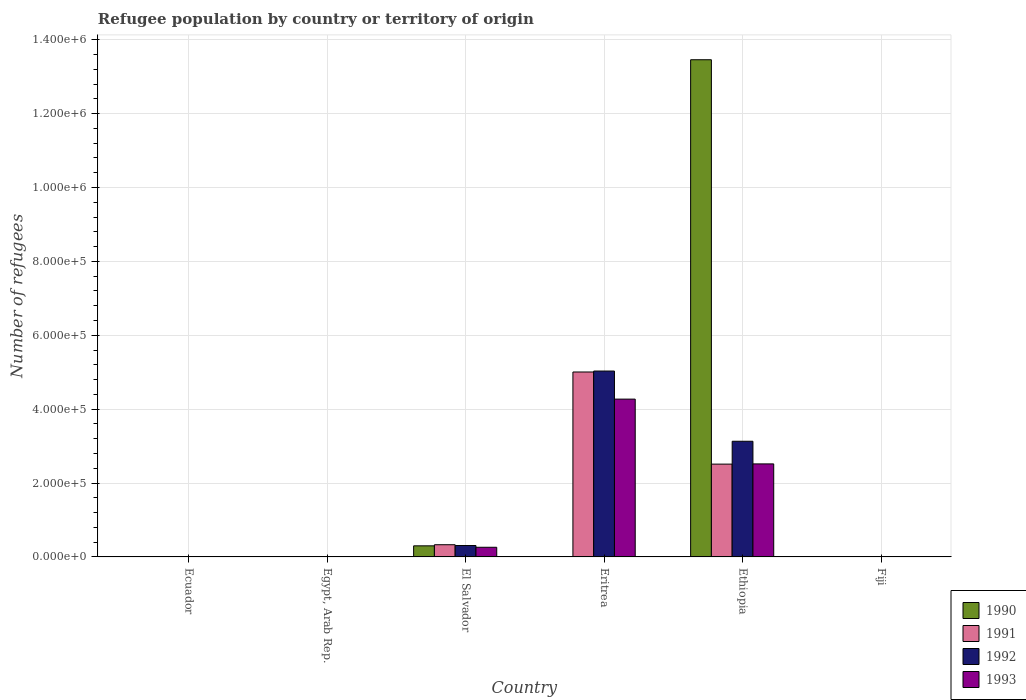How many different coloured bars are there?
Your answer should be very brief. 4. How many groups of bars are there?
Provide a succinct answer. 6. Are the number of bars on each tick of the X-axis equal?
Offer a terse response. Yes. How many bars are there on the 1st tick from the left?
Offer a very short reply. 4. What is the label of the 1st group of bars from the left?
Offer a terse response. Ecuador. What is the number of refugees in 1992 in Egypt, Arab Rep.?
Make the answer very short. 209. Across all countries, what is the maximum number of refugees in 1991?
Provide a succinct answer. 5.01e+05. In which country was the number of refugees in 1993 maximum?
Offer a very short reply. Eritrea. In which country was the number of refugees in 1993 minimum?
Keep it short and to the point. Ecuador. What is the total number of refugees in 1992 in the graph?
Offer a very short reply. 8.47e+05. What is the difference between the number of refugees in 1993 in Ethiopia and that in Fiji?
Your answer should be compact. 2.52e+05. What is the difference between the number of refugees in 1992 in Eritrea and the number of refugees in 1990 in Egypt, Arab Rep.?
Your response must be concise. 5.03e+05. What is the average number of refugees in 1992 per country?
Provide a succinct answer. 1.41e+05. What is the ratio of the number of refugees in 1993 in El Salvador to that in Eritrea?
Offer a very short reply. 0.06. Is the difference between the number of refugees in 1991 in Ethiopia and Fiji greater than the difference between the number of refugees in 1993 in Ethiopia and Fiji?
Your answer should be compact. No. What is the difference between the highest and the second highest number of refugees in 1991?
Offer a very short reply. 2.49e+05. What is the difference between the highest and the lowest number of refugees in 1990?
Your answer should be compact. 1.35e+06. What does the 1st bar from the right in Ethiopia represents?
Make the answer very short. 1993. Is it the case that in every country, the sum of the number of refugees in 1992 and number of refugees in 1991 is greater than the number of refugees in 1990?
Keep it short and to the point. No. How many bars are there?
Provide a short and direct response. 24. Are all the bars in the graph horizontal?
Your response must be concise. No. What is the difference between two consecutive major ticks on the Y-axis?
Provide a succinct answer. 2.00e+05. Does the graph contain any zero values?
Your response must be concise. No. Does the graph contain grids?
Keep it short and to the point. Yes. How many legend labels are there?
Your answer should be very brief. 4. How are the legend labels stacked?
Your answer should be compact. Vertical. What is the title of the graph?
Your answer should be compact. Refugee population by country or territory of origin. Does "1991" appear as one of the legend labels in the graph?
Offer a terse response. Yes. What is the label or title of the X-axis?
Your response must be concise. Country. What is the label or title of the Y-axis?
Give a very brief answer. Number of refugees. What is the Number of refugees in 1990 in Ecuador?
Make the answer very short. 3. What is the Number of refugees in 1991 in Ecuador?
Your answer should be compact. 27. What is the Number of refugees in 1991 in Egypt, Arab Rep.?
Your answer should be very brief. 97. What is the Number of refugees in 1992 in Egypt, Arab Rep.?
Provide a succinct answer. 209. What is the Number of refugees in 1993 in Egypt, Arab Rep.?
Your answer should be compact. 258. What is the Number of refugees of 1990 in El Salvador?
Keep it short and to the point. 3.00e+04. What is the Number of refugees in 1991 in El Salvador?
Your answer should be very brief. 3.30e+04. What is the Number of refugees in 1992 in El Salvador?
Offer a terse response. 3.09e+04. What is the Number of refugees of 1993 in El Salvador?
Offer a terse response. 2.61e+04. What is the Number of refugees in 1990 in Eritrea?
Offer a terse response. 43. What is the Number of refugees of 1991 in Eritrea?
Give a very brief answer. 5.01e+05. What is the Number of refugees in 1992 in Eritrea?
Keep it short and to the point. 5.03e+05. What is the Number of refugees in 1993 in Eritrea?
Provide a short and direct response. 4.27e+05. What is the Number of refugees of 1990 in Ethiopia?
Provide a short and direct response. 1.35e+06. What is the Number of refugees of 1991 in Ethiopia?
Offer a very short reply. 2.51e+05. What is the Number of refugees of 1992 in Ethiopia?
Your answer should be compact. 3.13e+05. What is the Number of refugees of 1993 in Ethiopia?
Your response must be concise. 2.52e+05. What is the Number of refugees of 1991 in Fiji?
Give a very brief answer. 1. What is the Number of refugees in 1993 in Fiji?
Offer a very short reply. 89. Across all countries, what is the maximum Number of refugees of 1990?
Your answer should be compact. 1.35e+06. Across all countries, what is the maximum Number of refugees in 1991?
Keep it short and to the point. 5.01e+05. Across all countries, what is the maximum Number of refugees of 1992?
Offer a terse response. 5.03e+05. Across all countries, what is the maximum Number of refugees of 1993?
Provide a short and direct response. 4.27e+05. Across all countries, what is the minimum Number of refugees of 1990?
Offer a terse response. 1. Across all countries, what is the minimum Number of refugees of 1991?
Give a very brief answer. 1. What is the total Number of refugees of 1990 in the graph?
Keep it short and to the point. 1.38e+06. What is the total Number of refugees in 1991 in the graph?
Make the answer very short. 7.85e+05. What is the total Number of refugees in 1992 in the graph?
Offer a terse response. 8.47e+05. What is the total Number of refugees of 1993 in the graph?
Your answer should be very brief. 7.06e+05. What is the difference between the Number of refugees of 1990 in Ecuador and that in Egypt, Arab Rep.?
Your answer should be compact. -45. What is the difference between the Number of refugees in 1991 in Ecuador and that in Egypt, Arab Rep.?
Ensure brevity in your answer.  -70. What is the difference between the Number of refugees in 1992 in Ecuador and that in Egypt, Arab Rep.?
Keep it short and to the point. -169. What is the difference between the Number of refugees of 1993 in Ecuador and that in Egypt, Arab Rep.?
Make the answer very short. -211. What is the difference between the Number of refugees of 1990 in Ecuador and that in El Salvador?
Provide a short and direct response. -3.00e+04. What is the difference between the Number of refugees in 1991 in Ecuador and that in El Salvador?
Ensure brevity in your answer.  -3.30e+04. What is the difference between the Number of refugees in 1992 in Ecuador and that in El Salvador?
Your answer should be compact. -3.08e+04. What is the difference between the Number of refugees of 1993 in Ecuador and that in El Salvador?
Offer a very short reply. -2.61e+04. What is the difference between the Number of refugees of 1991 in Ecuador and that in Eritrea?
Your answer should be compact. -5.01e+05. What is the difference between the Number of refugees of 1992 in Ecuador and that in Eritrea?
Offer a terse response. -5.03e+05. What is the difference between the Number of refugees of 1993 in Ecuador and that in Eritrea?
Provide a succinct answer. -4.27e+05. What is the difference between the Number of refugees in 1990 in Ecuador and that in Ethiopia?
Give a very brief answer. -1.35e+06. What is the difference between the Number of refugees in 1991 in Ecuador and that in Ethiopia?
Ensure brevity in your answer.  -2.51e+05. What is the difference between the Number of refugees of 1992 in Ecuador and that in Ethiopia?
Your answer should be compact. -3.13e+05. What is the difference between the Number of refugees of 1993 in Ecuador and that in Ethiopia?
Offer a very short reply. -2.52e+05. What is the difference between the Number of refugees of 1992 in Ecuador and that in Fiji?
Your answer should be very brief. 21. What is the difference between the Number of refugees in 1993 in Ecuador and that in Fiji?
Your answer should be compact. -42. What is the difference between the Number of refugees of 1990 in Egypt, Arab Rep. and that in El Salvador?
Your response must be concise. -3.00e+04. What is the difference between the Number of refugees of 1991 in Egypt, Arab Rep. and that in El Salvador?
Your answer should be compact. -3.30e+04. What is the difference between the Number of refugees of 1992 in Egypt, Arab Rep. and that in El Salvador?
Ensure brevity in your answer.  -3.06e+04. What is the difference between the Number of refugees of 1993 in Egypt, Arab Rep. and that in El Salvador?
Your response must be concise. -2.59e+04. What is the difference between the Number of refugees in 1990 in Egypt, Arab Rep. and that in Eritrea?
Your answer should be very brief. 5. What is the difference between the Number of refugees of 1991 in Egypt, Arab Rep. and that in Eritrea?
Your answer should be compact. -5.01e+05. What is the difference between the Number of refugees in 1992 in Egypt, Arab Rep. and that in Eritrea?
Your answer should be compact. -5.03e+05. What is the difference between the Number of refugees in 1993 in Egypt, Arab Rep. and that in Eritrea?
Ensure brevity in your answer.  -4.27e+05. What is the difference between the Number of refugees of 1990 in Egypt, Arab Rep. and that in Ethiopia?
Make the answer very short. -1.35e+06. What is the difference between the Number of refugees of 1991 in Egypt, Arab Rep. and that in Ethiopia?
Your answer should be very brief. -2.51e+05. What is the difference between the Number of refugees in 1992 in Egypt, Arab Rep. and that in Ethiopia?
Keep it short and to the point. -3.13e+05. What is the difference between the Number of refugees of 1993 in Egypt, Arab Rep. and that in Ethiopia?
Provide a succinct answer. -2.52e+05. What is the difference between the Number of refugees in 1991 in Egypt, Arab Rep. and that in Fiji?
Keep it short and to the point. 96. What is the difference between the Number of refugees of 1992 in Egypt, Arab Rep. and that in Fiji?
Give a very brief answer. 190. What is the difference between the Number of refugees in 1993 in Egypt, Arab Rep. and that in Fiji?
Make the answer very short. 169. What is the difference between the Number of refugees of 1990 in El Salvador and that in Eritrea?
Your answer should be compact. 3.00e+04. What is the difference between the Number of refugees in 1991 in El Salvador and that in Eritrea?
Offer a terse response. -4.68e+05. What is the difference between the Number of refugees in 1992 in El Salvador and that in Eritrea?
Your answer should be compact. -4.72e+05. What is the difference between the Number of refugees in 1993 in El Salvador and that in Eritrea?
Your response must be concise. -4.01e+05. What is the difference between the Number of refugees in 1990 in El Salvador and that in Ethiopia?
Offer a very short reply. -1.32e+06. What is the difference between the Number of refugees of 1991 in El Salvador and that in Ethiopia?
Ensure brevity in your answer.  -2.18e+05. What is the difference between the Number of refugees of 1992 in El Salvador and that in Ethiopia?
Provide a succinct answer. -2.82e+05. What is the difference between the Number of refugees of 1993 in El Salvador and that in Ethiopia?
Your answer should be compact. -2.26e+05. What is the difference between the Number of refugees in 1990 in El Salvador and that in Fiji?
Your answer should be very brief. 3.00e+04. What is the difference between the Number of refugees in 1991 in El Salvador and that in Fiji?
Your answer should be very brief. 3.30e+04. What is the difference between the Number of refugees of 1992 in El Salvador and that in Fiji?
Offer a terse response. 3.08e+04. What is the difference between the Number of refugees in 1993 in El Salvador and that in Fiji?
Make the answer very short. 2.60e+04. What is the difference between the Number of refugees in 1990 in Eritrea and that in Ethiopia?
Offer a terse response. -1.35e+06. What is the difference between the Number of refugees of 1991 in Eritrea and that in Ethiopia?
Offer a very short reply. 2.49e+05. What is the difference between the Number of refugees in 1992 in Eritrea and that in Ethiopia?
Offer a terse response. 1.90e+05. What is the difference between the Number of refugees of 1993 in Eritrea and that in Ethiopia?
Ensure brevity in your answer.  1.75e+05. What is the difference between the Number of refugees of 1991 in Eritrea and that in Fiji?
Provide a succinct answer. 5.01e+05. What is the difference between the Number of refugees in 1992 in Eritrea and that in Fiji?
Ensure brevity in your answer.  5.03e+05. What is the difference between the Number of refugees in 1993 in Eritrea and that in Fiji?
Provide a short and direct response. 4.27e+05. What is the difference between the Number of refugees of 1990 in Ethiopia and that in Fiji?
Make the answer very short. 1.35e+06. What is the difference between the Number of refugees in 1991 in Ethiopia and that in Fiji?
Provide a short and direct response. 2.51e+05. What is the difference between the Number of refugees of 1992 in Ethiopia and that in Fiji?
Make the answer very short. 3.13e+05. What is the difference between the Number of refugees of 1993 in Ethiopia and that in Fiji?
Offer a terse response. 2.52e+05. What is the difference between the Number of refugees in 1990 in Ecuador and the Number of refugees in 1991 in Egypt, Arab Rep.?
Provide a short and direct response. -94. What is the difference between the Number of refugees of 1990 in Ecuador and the Number of refugees of 1992 in Egypt, Arab Rep.?
Provide a succinct answer. -206. What is the difference between the Number of refugees in 1990 in Ecuador and the Number of refugees in 1993 in Egypt, Arab Rep.?
Provide a short and direct response. -255. What is the difference between the Number of refugees in 1991 in Ecuador and the Number of refugees in 1992 in Egypt, Arab Rep.?
Make the answer very short. -182. What is the difference between the Number of refugees of 1991 in Ecuador and the Number of refugees of 1993 in Egypt, Arab Rep.?
Ensure brevity in your answer.  -231. What is the difference between the Number of refugees of 1992 in Ecuador and the Number of refugees of 1993 in Egypt, Arab Rep.?
Offer a terse response. -218. What is the difference between the Number of refugees of 1990 in Ecuador and the Number of refugees of 1991 in El Salvador?
Offer a terse response. -3.30e+04. What is the difference between the Number of refugees in 1990 in Ecuador and the Number of refugees in 1992 in El Salvador?
Keep it short and to the point. -3.09e+04. What is the difference between the Number of refugees in 1990 in Ecuador and the Number of refugees in 1993 in El Salvador?
Give a very brief answer. -2.61e+04. What is the difference between the Number of refugees of 1991 in Ecuador and the Number of refugees of 1992 in El Salvador?
Keep it short and to the point. -3.08e+04. What is the difference between the Number of refugees of 1991 in Ecuador and the Number of refugees of 1993 in El Salvador?
Your response must be concise. -2.61e+04. What is the difference between the Number of refugees of 1992 in Ecuador and the Number of refugees of 1993 in El Salvador?
Provide a succinct answer. -2.61e+04. What is the difference between the Number of refugees in 1990 in Ecuador and the Number of refugees in 1991 in Eritrea?
Offer a very short reply. -5.01e+05. What is the difference between the Number of refugees in 1990 in Ecuador and the Number of refugees in 1992 in Eritrea?
Offer a terse response. -5.03e+05. What is the difference between the Number of refugees in 1990 in Ecuador and the Number of refugees in 1993 in Eritrea?
Give a very brief answer. -4.27e+05. What is the difference between the Number of refugees in 1991 in Ecuador and the Number of refugees in 1992 in Eritrea?
Provide a succinct answer. -5.03e+05. What is the difference between the Number of refugees of 1991 in Ecuador and the Number of refugees of 1993 in Eritrea?
Offer a very short reply. -4.27e+05. What is the difference between the Number of refugees in 1992 in Ecuador and the Number of refugees in 1993 in Eritrea?
Give a very brief answer. -4.27e+05. What is the difference between the Number of refugees of 1990 in Ecuador and the Number of refugees of 1991 in Ethiopia?
Your answer should be very brief. -2.51e+05. What is the difference between the Number of refugees of 1990 in Ecuador and the Number of refugees of 1992 in Ethiopia?
Give a very brief answer. -3.13e+05. What is the difference between the Number of refugees of 1990 in Ecuador and the Number of refugees of 1993 in Ethiopia?
Provide a succinct answer. -2.52e+05. What is the difference between the Number of refugees of 1991 in Ecuador and the Number of refugees of 1992 in Ethiopia?
Offer a terse response. -3.13e+05. What is the difference between the Number of refugees in 1991 in Ecuador and the Number of refugees in 1993 in Ethiopia?
Your answer should be compact. -2.52e+05. What is the difference between the Number of refugees of 1992 in Ecuador and the Number of refugees of 1993 in Ethiopia?
Offer a terse response. -2.52e+05. What is the difference between the Number of refugees in 1990 in Ecuador and the Number of refugees in 1992 in Fiji?
Offer a very short reply. -16. What is the difference between the Number of refugees in 1990 in Ecuador and the Number of refugees in 1993 in Fiji?
Make the answer very short. -86. What is the difference between the Number of refugees of 1991 in Ecuador and the Number of refugees of 1993 in Fiji?
Make the answer very short. -62. What is the difference between the Number of refugees in 1992 in Ecuador and the Number of refugees in 1993 in Fiji?
Offer a very short reply. -49. What is the difference between the Number of refugees of 1990 in Egypt, Arab Rep. and the Number of refugees of 1991 in El Salvador?
Keep it short and to the point. -3.30e+04. What is the difference between the Number of refugees of 1990 in Egypt, Arab Rep. and the Number of refugees of 1992 in El Salvador?
Provide a short and direct response. -3.08e+04. What is the difference between the Number of refugees of 1990 in Egypt, Arab Rep. and the Number of refugees of 1993 in El Salvador?
Ensure brevity in your answer.  -2.61e+04. What is the difference between the Number of refugees in 1991 in Egypt, Arab Rep. and the Number of refugees in 1992 in El Salvador?
Provide a short and direct response. -3.08e+04. What is the difference between the Number of refugees of 1991 in Egypt, Arab Rep. and the Number of refugees of 1993 in El Salvador?
Your answer should be compact. -2.60e+04. What is the difference between the Number of refugees of 1992 in Egypt, Arab Rep. and the Number of refugees of 1993 in El Salvador?
Ensure brevity in your answer.  -2.59e+04. What is the difference between the Number of refugees in 1990 in Egypt, Arab Rep. and the Number of refugees in 1991 in Eritrea?
Provide a short and direct response. -5.01e+05. What is the difference between the Number of refugees of 1990 in Egypt, Arab Rep. and the Number of refugees of 1992 in Eritrea?
Keep it short and to the point. -5.03e+05. What is the difference between the Number of refugees in 1990 in Egypt, Arab Rep. and the Number of refugees in 1993 in Eritrea?
Provide a short and direct response. -4.27e+05. What is the difference between the Number of refugees in 1991 in Egypt, Arab Rep. and the Number of refugees in 1992 in Eritrea?
Your answer should be very brief. -5.03e+05. What is the difference between the Number of refugees in 1991 in Egypt, Arab Rep. and the Number of refugees in 1993 in Eritrea?
Offer a very short reply. -4.27e+05. What is the difference between the Number of refugees in 1992 in Egypt, Arab Rep. and the Number of refugees in 1993 in Eritrea?
Your answer should be compact. -4.27e+05. What is the difference between the Number of refugees of 1990 in Egypt, Arab Rep. and the Number of refugees of 1991 in Ethiopia?
Ensure brevity in your answer.  -2.51e+05. What is the difference between the Number of refugees of 1990 in Egypt, Arab Rep. and the Number of refugees of 1992 in Ethiopia?
Ensure brevity in your answer.  -3.13e+05. What is the difference between the Number of refugees in 1990 in Egypt, Arab Rep. and the Number of refugees in 1993 in Ethiopia?
Your response must be concise. -2.52e+05. What is the difference between the Number of refugees in 1991 in Egypt, Arab Rep. and the Number of refugees in 1992 in Ethiopia?
Your answer should be very brief. -3.13e+05. What is the difference between the Number of refugees of 1991 in Egypt, Arab Rep. and the Number of refugees of 1993 in Ethiopia?
Keep it short and to the point. -2.52e+05. What is the difference between the Number of refugees in 1992 in Egypt, Arab Rep. and the Number of refugees in 1993 in Ethiopia?
Provide a succinct answer. -2.52e+05. What is the difference between the Number of refugees of 1990 in Egypt, Arab Rep. and the Number of refugees of 1991 in Fiji?
Keep it short and to the point. 47. What is the difference between the Number of refugees of 1990 in Egypt, Arab Rep. and the Number of refugees of 1992 in Fiji?
Make the answer very short. 29. What is the difference between the Number of refugees in 1990 in Egypt, Arab Rep. and the Number of refugees in 1993 in Fiji?
Offer a very short reply. -41. What is the difference between the Number of refugees of 1991 in Egypt, Arab Rep. and the Number of refugees of 1992 in Fiji?
Keep it short and to the point. 78. What is the difference between the Number of refugees of 1992 in Egypt, Arab Rep. and the Number of refugees of 1993 in Fiji?
Ensure brevity in your answer.  120. What is the difference between the Number of refugees of 1990 in El Salvador and the Number of refugees of 1991 in Eritrea?
Your answer should be very brief. -4.71e+05. What is the difference between the Number of refugees in 1990 in El Salvador and the Number of refugees in 1992 in Eritrea?
Your answer should be compact. -4.73e+05. What is the difference between the Number of refugees of 1990 in El Salvador and the Number of refugees of 1993 in Eritrea?
Offer a very short reply. -3.97e+05. What is the difference between the Number of refugees in 1991 in El Salvador and the Number of refugees in 1992 in Eritrea?
Offer a very short reply. -4.70e+05. What is the difference between the Number of refugees in 1991 in El Salvador and the Number of refugees in 1993 in Eritrea?
Ensure brevity in your answer.  -3.94e+05. What is the difference between the Number of refugees in 1992 in El Salvador and the Number of refugees in 1993 in Eritrea?
Offer a terse response. -3.96e+05. What is the difference between the Number of refugees in 1990 in El Salvador and the Number of refugees in 1991 in Ethiopia?
Provide a short and direct response. -2.21e+05. What is the difference between the Number of refugees of 1990 in El Salvador and the Number of refugees of 1992 in Ethiopia?
Offer a terse response. -2.83e+05. What is the difference between the Number of refugees of 1990 in El Salvador and the Number of refugees of 1993 in Ethiopia?
Provide a short and direct response. -2.22e+05. What is the difference between the Number of refugees of 1991 in El Salvador and the Number of refugees of 1992 in Ethiopia?
Provide a short and direct response. -2.80e+05. What is the difference between the Number of refugees in 1991 in El Salvador and the Number of refugees in 1993 in Ethiopia?
Ensure brevity in your answer.  -2.19e+05. What is the difference between the Number of refugees of 1992 in El Salvador and the Number of refugees of 1993 in Ethiopia?
Keep it short and to the point. -2.21e+05. What is the difference between the Number of refugees in 1990 in El Salvador and the Number of refugees in 1991 in Fiji?
Offer a very short reply. 3.00e+04. What is the difference between the Number of refugees of 1990 in El Salvador and the Number of refugees of 1993 in Fiji?
Keep it short and to the point. 2.99e+04. What is the difference between the Number of refugees in 1991 in El Salvador and the Number of refugees in 1992 in Fiji?
Offer a terse response. 3.30e+04. What is the difference between the Number of refugees of 1991 in El Salvador and the Number of refugees of 1993 in Fiji?
Ensure brevity in your answer.  3.30e+04. What is the difference between the Number of refugees of 1992 in El Salvador and the Number of refugees of 1993 in Fiji?
Provide a short and direct response. 3.08e+04. What is the difference between the Number of refugees of 1990 in Eritrea and the Number of refugees of 1991 in Ethiopia?
Ensure brevity in your answer.  -2.51e+05. What is the difference between the Number of refugees of 1990 in Eritrea and the Number of refugees of 1992 in Ethiopia?
Provide a succinct answer. -3.13e+05. What is the difference between the Number of refugees in 1990 in Eritrea and the Number of refugees in 1993 in Ethiopia?
Ensure brevity in your answer.  -2.52e+05. What is the difference between the Number of refugees of 1991 in Eritrea and the Number of refugees of 1992 in Ethiopia?
Provide a short and direct response. 1.88e+05. What is the difference between the Number of refugees of 1991 in Eritrea and the Number of refugees of 1993 in Ethiopia?
Your response must be concise. 2.49e+05. What is the difference between the Number of refugees of 1992 in Eritrea and the Number of refugees of 1993 in Ethiopia?
Your answer should be compact. 2.51e+05. What is the difference between the Number of refugees of 1990 in Eritrea and the Number of refugees of 1991 in Fiji?
Make the answer very short. 42. What is the difference between the Number of refugees of 1990 in Eritrea and the Number of refugees of 1993 in Fiji?
Provide a succinct answer. -46. What is the difference between the Number of refugees in 1991 in Eritrea and the Number of refugees in 1992 in Fiji?
Your answer should be compact. 5.01e+05. What is the difference between the Number of refugees in 1991 in Eritrea and the Number of refugees in 1993 in Fiji?
Give a very brief answer. 5.01e+05. What is the difference between the Number of refugees of 1992 in Eritrea and the Number of refugees of 1993 in Fiji?
Provide a succinct answer. 5.03e+05. What is the difference between the Number of refugees of 1990 in Ethiopia and the Number of refugees of 1991 in Fiji?
Offer a very short reply. 1.35e+06. What is the difference between the Number of refugees in 1990 in Ethiopia and the Number of refugees in 1992 in Fiji?
Provide a short and direct response. 1.35e+06. What is the difference between the Number of refugees in 1990 in Ethiopia and the Number of refugees in 1993 in Fiji?
Give a very brief answer. 1.35e+06. What is the difference between the Number of refugees in 1991 in Ethiopia and the Number of refugees in 1992 in Fiji?
Make the answer very short. 2.51e+05. What is the difference between the Number of refugees of 1991 in Ethiopia and the Number of refugees of 1993 in Fiji?
Offer a very short reply. 2.51e+05. What is the difference between the Number of refugees of 1992 in Ethiopia and the Number of refugees of 1993 in Fiji?
Keep it short and to the point. 3.13e+05. What is the average Number of refugees of 1990 per country?
Provide a short and direct response. 2.29e+05. What is the average Number of refugees in 1991 per country?
Offer a terse response. 1.31e+05. What is the average Number of refugees of 1992 per country?
Ensure brevity in your answer.  1.41e+05. What is the average Number of refugees in 1993 per country?
Give a very brief answer. 1.18e+05. What is the difference between the Number of refugees of 1990 and Number of refugees of 1992 in Ecuador?
Offer a very short reply. -37. What is the difference between the Number of refugees in 1990 and Number of refugees in 1993 in Ecuador?
Provide a succinct answer. -44. What is the difference between the Number of refugees of 1991 and Number of refugees of 1992 in Ecuador?
Provide a short and direct response. -13. What is the difference between the Number of refugees of 1992 and Number of refugees of 1993 in Ecuador?
Ensure brevity in your answer.  -7. What is the difference between the Number of refugees in 1990 and Number of refugees in 1991 in Egypt, Arab Rep.?
Keep it short and to the point. -49. What is the difference between the Number of refugees in 1990 and Number of refugees in 1992 in Egypt, Arab Rep.?
Your response must be concise. -161. What is the difference between the Number of refugees in 1990 and Number of refugees in 1993 in Egypt, Arab Rep.?
Provide a short and direct response. -210. What is the difference between the Number of refugees of 1991 and Number of refugees of 1992 in Egypt, Arab Rep.?
Your response must be concise. -112. What is the difference between the Number of refugees in 1991 and Number of refugees in 1993 in Egypt, Arab Rep.?
Your answer should be compact. -161. What is the difference between the Number of refugees in 1992 and Number of refugees in 1993 in Egypt, Arab Rep.?
Your answer should be compact. -49. What is the difference between the Number of refugees in 1990 and Number of refugees in 1991 in El Salvador?
Your response must be concise. -3030. What is the difference between the Number of refugees in 1990 and Number of refugees in 1992 in El Salvador?
Ensure brevity in your answer.  -836. What is the difference between the Number of refugees in 1990 and Number of refugees in 1993 in El Salvador?
Provide a succinct answer. 3895. What is the difference between the Number of refugees of 1991 and Number of refugees of 1992 in El Salvador?
Your answer should be compact. 2194. What is the difference between the Number of refugees of 1991 and Number of refugees of 1993 in El Salvador?
Offer a very short reply. 6925. What is the difference between the Number of refugees in 1992 and Number of refugees in 1993 in El Salvador?
Your answer should be compact. 4731. What is the difference between the Number of refugees of 1990 and Number of refugees of 1991 in Eritrea?
Provide a short and direct response. -5.01e+05. What is the difference between the Number of refugees in 1990 and Number of refugees in 1992 in Eritrea?
Give a very brief answer. -5.03e+05. What is the difference between the Number of refugees of 1990 and Number of refugees of 1993 in Eritrea?
Give a very brief answer. -4.27e+05. What is the difference between the Number of refugees of 1991 and Number of refugees of 1992 in Eritrea?
Provide a succinct answer. -2567. What is the difference between the Number of refugees of 1991 and Number of refugees of 1993 in Eritrea?
Your answer should be very brief. 7.34e+04. What is the difference between the Number of refugees in 1992 and Number of refugees in 1993 in Eritrea?
Provide a short and direct response. 7.60e+04. What is the difference between the Number of refugees in 1990 and Number of refugees in 1991 in Ethiopia?
Make the answer very short. 1.09e+06. What is the difference between the Number of refugees in 1990 and Number of refugees in 1992 in Ethiopia?
Give a very brief answer. 1.03e+06. What is the difference between the Number of refugees in 1990 and Number of refugees in 1993 in Ethiopia?
Offer a very short reply. 1.09e+06. What is the difference between the Number of refugees of 1991 and Number of refugees of 1992 in Ethiopia?
Offer a terse response. -6.19e+04. What is the difference between the Number of refugees of 1991 and Number of refugees of 1993 in Ethiopia?
Offer a very short reply. -587. What is the difference between the Number of refugees of 1992 and Number of refugees of 1993 in Ethiopia?
Your response must be concise. 6.13e+04. What is the difference between the Number of refugees in 1990 and Number of refugees in 1992 in Fiji?
Make the answer very short. -18. What is the difference between the Number of refugees in 1990 and Number of refugees in 1993 in Fiji?
Offer a terse response. -88. What is the difference between the Number of refugees in 1991 and Number of refugees in 1993 in Fiji?
Offer a very short reply. -88. What is the difference between the Number of refugees of 1992 and Number of refugees of 1993 in Fiji?
Offer a terse response. -70. What is the ratio of the Number of refugees in 1990 in Ecuador to that in Egypt, Arab Rep.?
Provide a short and direct response. 0.06. What is the ratio of the Number of refugees of 1991 in Ecuador to that in Egypt, Arab Rep.?
Your answer should be very brief. 0.28. What is the ratio of the Number of refugees of 1992 in Ecuador to that in Egypt, Arab Rep.?
Offer a very short reply. 0.19. What is the ratio of the Number of refugees of 1993 in Ecuador to that in Egypt, Arab Rep.?
Keep it short and to the point. 0.18. What is the ratio of the Number of refugees in 1990 in Ecuador to that in El Salvador?
Your answer should be compact. 0. What is the ratio of the Number of refugees of 1991 in Ecuador to that in El Salvador?
Offer a terse response. 0. What is the ratio of the Number of refugees in 1992 in Ecuador to that in El Salvador?
Provide a succinct answer. 0. What is the ratio of the Number of refugees of 1993 in Ecuador to that in El Salvador?
Make the answer very short. 0. What is the ratio of the Number of refugees of 1990 in Ecuador to that in Eritrea?
Offer a very short reply. 0.07. What is the ratio of the Number of refugees in 1992 in Ecuador to that in Eritrea?
Give a very brief answer. 0. What is the ratio of the Number of refugees of 1990 in Ecuador to that in Ethiopia?
Give a very brief answer. 0. What is the ratio of the Number of refugees of 1991 in Ecuador to that in Ethiopia?
Offer a terse response. 0. What is the ratio of the Number of refugees in 1991 in Ecuador to that in Fiji?
Provide a succinct answer. 27. What is the ratio of the Number of refugees of 1992 in Ecuador to that in Fiji?
Give a very brief answer. 2.11. What is the ratio of the Number of refugees of 1993 in Ecuador to that in Fiji?
Your answer should be compact. 0.53. What is the ratio of the Number of refugees in 1990 in Egypt, Arab Rep. to that in El Salvador?
Make the answer very short. 0. What is the ratio of the Number of refugees of 1991 in Egypt, Arab Rep. to that in El Salvador?
Provide a succinct answer. 0. What is the ratio of the Number of refugees of 1992 in Egypt, Arab Rep. to that in El Salvador?
Your answer should be very brief. 0.01. What is the ratio of the Number of refugees of 1993 in Egypt, Arab Rep. to that in El Salvador?
Your answer should be compact. 0.01. What is the ratio of the Number of refugees in 1990 in Egypt, Arab Rep. to that in Eritrea?
Offer a very short reply. 1.12. What is the ratio of the Number of refugees in 1991 in Egypt, Arab Rep. to that in Eritrea?
Offer a very short reply. 0. What is the ratio of the Number of refugees in 1992 in Egypt, Arab Rep. to that in Eritrea?
Your response must be concise. 0. What is the ratio of the Number of refugees in 1993 in Egypt, Arab Rep. to that in Eritrea?
Ensure brevity in your answer.  0. What is the ratio of the Number of refugees of 1992 in Egypt, Arab Rep. to that in Ethiopia?
Your answer should be compact. 0. What is the ratio of the Number of refugees of 1993 in Egypt, Arab Rep. to that in Ethiopia?
Provide a succinct answer. 0. What is the ratio of the Number of refugees in 1991 in Egypt, Arab Rep. to that in Fiji?
Keep it short and to the point. 97. What is the ratio of the Number of refugees in 1992 in Egypt, Arab Rep. to that in Fiji?
Provide a succinct answer. 11. What is the ratio of the Number of refugees of 1993 in Egypt, Arab Rep. to that in Fiji?
Make the answer very short. 2.9. What is the ratio of the Number of refugees of 1990 in El Salvador to that in Eritrea?
Your answer should be very brief. 698.12. What is the ratio of the Number of refugees of 1991 in El Salvador to that in Eritrea?
Provide a short and direct response. 0.07. What is the ratio of the Number of refugees of 1992 in El Salvador to that in Eritrea?
Make the answer very short. 0.06. What is the ratio of the Number of refugees of 1993 in El Salvador to that in Eritrea?
Your answer should be very brief. 0.06. What is the ratio of the Number of refugees of 1990 in El Salvador to that in Ethiopia?
Provide a short and direct response. 0.02. What is the ratio of the Number of refugees in 1991 in El Salvador to that in Ethiopia?
Your answer should be compact. 0.13. What is the ratio of the Number of refugees of 1992 in El Salvador to that in Ethiopia?
Ensure brevity in your answer.  0.1. What is the ratio of the Number of refugees of 1993 in El Salvador to that in Ethiopia?
Give a very brief answer. 0.1. What is the ratio of the Number of refugees of 1990 in El Salvador to that in Fiji?
Your answer should be very brief. 3.00e+04. What is the ratio of the Number of refugees in 1991 in El Salvador to that in Fiji?
Make the answer very short. 3.30e+04. What is the ratio of the Number of refugees of 1992 in El Salvador to that in Fiji?
Your answer should be very brief. 1623.95. What is the ratio of the Number of refugees in 1993 in El Salvador to that in Fiji?
Provide a short and direct response. 293.53. What is the ratio of the Number of refugees in 1991 in Eritrea to that in Ethiopia?
Make the answer very short. 1.99. What is the ratio of the Number of refugees in 1992 in Eritrea to that in Ethiopia?
Offer a very short reply. 1.61. What is the ratio of the Number of refugees in 1993 in Eritrea to that in Ethiopia?
Your response must be concise. 1.7. What is the ratio of the Number of refugees in 1991 in Eritrea to that in Fiji?
Your response must be concise. 5.01e+05. What is the ratio of the Number of refugees of 1992 in Eritrea to that in Fiji?
Provide a succinct answer. 2.65e+04. What is the ratio of the Number of refugees in 1993 in Eritrea to that in Fiji?
Your answer should be very brief. 4800.15. What is the ratio of the Number of refugees in 1990 in Ethiopia to that in Fiji?
Offer a very short reply. 1.35e+06. What is the ratio of the Number of refugees of 1991 in Ethiopia to that in Fiji?
Your answer should be compact. 2.51e+05. What is the ratio of the Number of refugees in 1992 in Ethiopia to that in Fiji?
Your answer should be very brief. 1.65e+04. What is the ratio of the Number of refugees of 1993 in Ethiopia to that in Fiji?
Your answer should be compact. 2829.53. What is the difference between the highest and the second highest Number of refugees of 1990?
Offer a very short reply. 1.32e+06. What is the difference between the highest and the second highest Number of refugees of 1991?
Ensure brevity in your answer.  2.49e+05. What is the difference between the highest and the second highest Number of refugees of 1992?
Your answer should be very brief. 1.90e+05. What is the difference between the highest and the second highest Number of refugees in 1993?
Ensure brevity in your answer.  1.75e+05. What is the difference between the highest and the lowest Number of refugees of 1990?
Ensure brevity in your answer.  1.35e+06. What is the difference between the highest and the lowest Number of refugees of 1991?
Give a very brief answer. 5.01e+05. What is the difference between the highest and the lowest Number of refugees of 1992?
Offer a very short reply. 5.03e+05. What is the difference between the highest and the lowest Number of refugees of 1993?
Provide a succinct answer. 4.27e+05. 